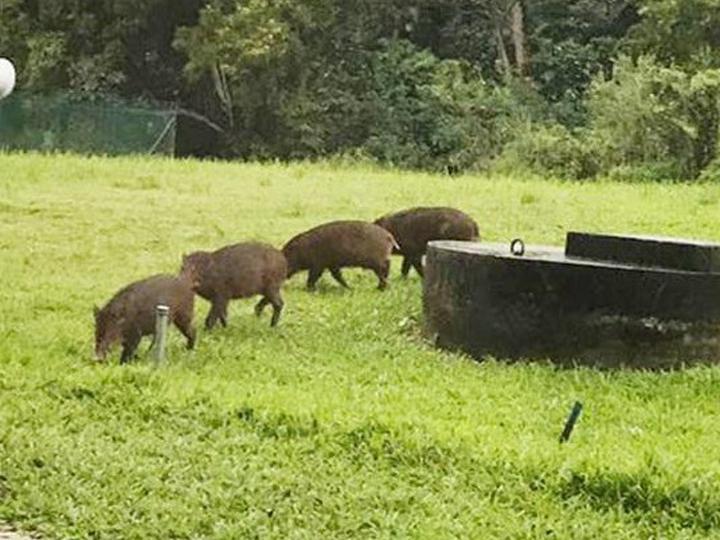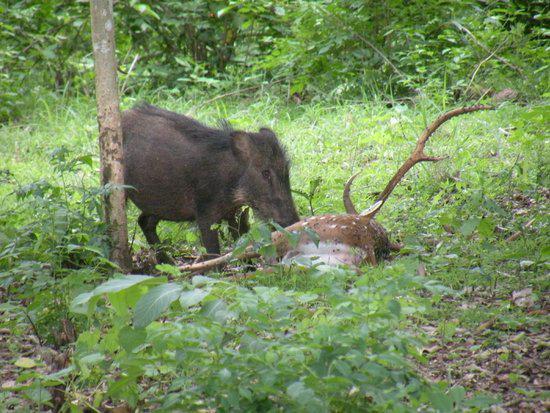The first image is the image on the left, the second image is the image on the right. Evaluate the accuracy of this statement regarding the images: "There is at least one dog in the right image.". Is it true? Answer yes or no. No. 